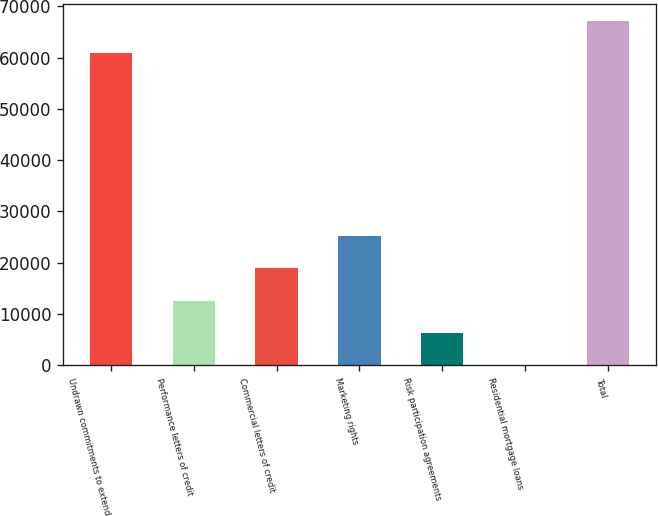<chart> <loc_0><loc_0><loc_500><loc_500><bar_chart><fcel>Undrawn commitments to extend<fcel>Performance letters of credit<fcel>Commercial letters of credit<fcel>Marketing rights<fcel>Risk participation agreements<fcel>Residential mortgage loans<fcel>Total<nl><fcel>60872<fcel>12590<fcel>18881<fcel>25172<fcel>6299<fcel>8<fcel>67163<nl></chart> 